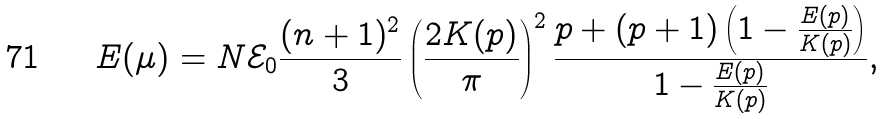<formula> <loc_0><loc_0><loc_500><loc_500>E ( \mu ) = N \mathcal { E } _ { 0 } \frac { ( n + 1 ) ^ { 2 } } { 3 } \left ( \frac { 2 K ( p ) } { \pi } \right ) ^ { 2 } \frac { p + ( p + 1 ) \left ( 1 - \frac { E ( p ) } { K ( p ) } \right ) } { 1 - \frac { E ( p ) } { K ( p ) } } ,</formula> 